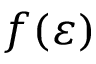<formula> <loc_0><loc_0><loc_500><loc_500>f ( \varepsilon )</formula> 